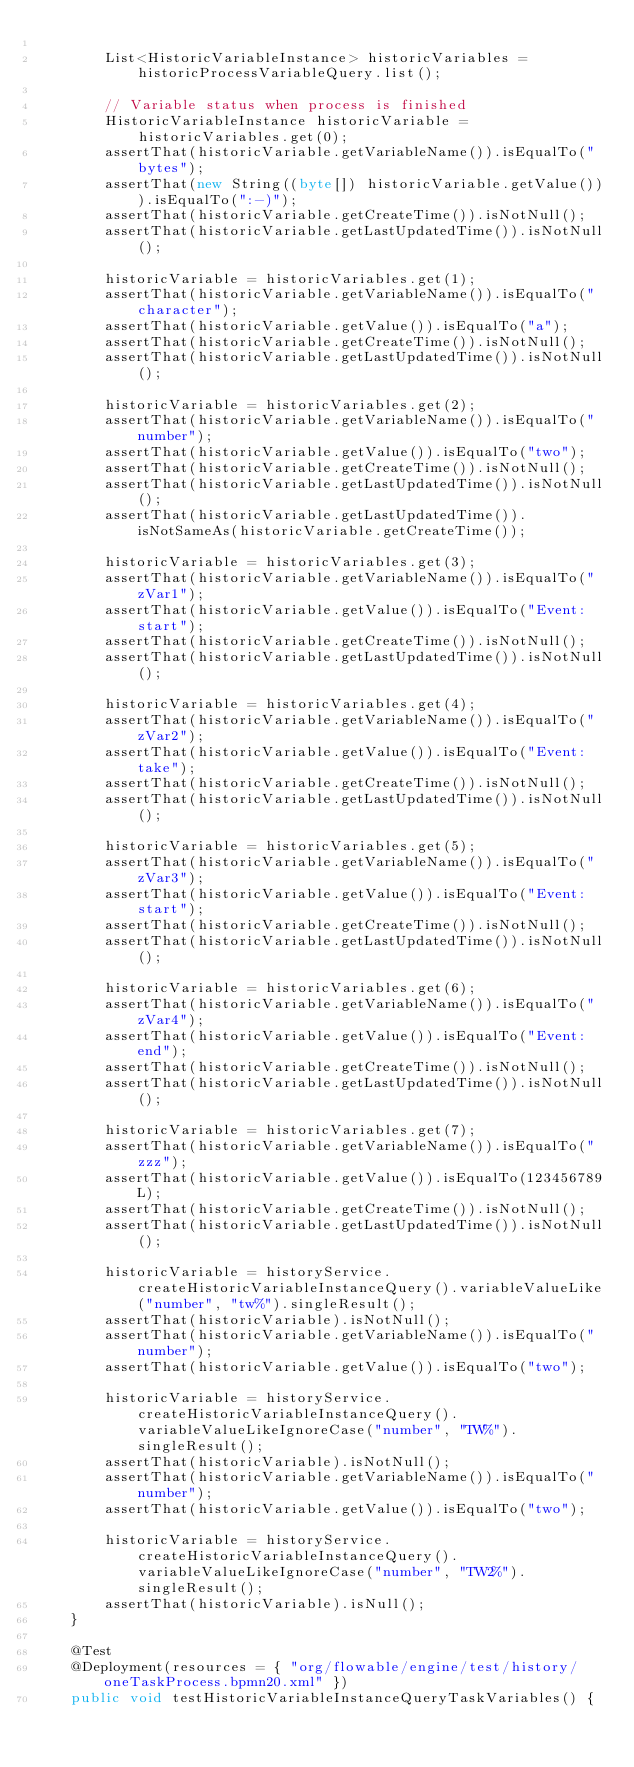Convert code to text. <code><loc_0><loc_0><loc_500><loc_500><_Java_>
        List<HistoricVariableInstance> historicVariables = historicProcessVariableQuery.list();

        // Variable status when process is finished
        HistoricVariableInstance historicVariable = historicVariables.get(0);
        assertThat(historicVariable.getVariableName()).isEqualTo("bytes");
        assertThat(new String((byte[]) historicVariable.getValue())).isEqualTo(":-)");
        assertThat(historicVariable.getCreateTime()).isNotNull();
        assertThat(historicVariable.getLastUpdatedTime()).isNotNull();

        historicVariable = historicVariables.get(1);
        assertThat(historicVariable.getVariableName()).isEqualTo("character");
        assertThat(historicVariable.getValue()).isEqualTo("a");
        assertThat(historicVariable.getCreateTime()).isNotNull();
        assertThat(historicVariable.getLastUpdatedTime()).isNotNull();

        historicVariable = historicVariables.get(2);
        assertThat(historicVariable.getVariableName()).isEqualTo("number");
        assertThat(historicVariable.getValue()).isEqualTo("two");
        assertThat(historicVariable.getCreateTime()).isNotNull();
        assertThat(historicVariable.getLastUpdatedTime()).isNotNull();
        assertThat(historicVariable.getLastUpdatedTime()).isNotSameAs(historicVariable.getCreateTime());

        historicVariable = historicVariables.get(3);
        assertThat(historicVariable.getVariableName()).isEqualTo("zVar1");
        assertThat(historicVariable.getValue()).isEqualTo("Event: start");
        assertThat(historicVariable.getCreateTime()).isNotNull();
        assertThat(historicVariable.getLastUpdatedTime()).isNotNull();

        historicVariable = historicVariables.get(4);
        assertThat(historicVariable.getVariableName()).isEqualTo("zVar2");
        assertThat(historicVariable.getValue()).isEqualTo("Event: take");
        assertThat(historicVariable.getCreateTime()).isNotNull();
        assertThat(historicVariable.getLastUpdatedTime()).isNotNull();

        historicVariable = historicVariables.get(5);
        assertThat(historicVariable.getVariableName()).isEqualTo("zVar3");
        assertThat(historicVariable.getValue()).isEqualTo("Event: start");
        assertThat(historicVariable.getCreateTime()).isNotNull();
        assertThat(historicVariable.getLastUpdatedTime()).isNotNull();

        historicVariable = historicVariables.get(6);
        assertThat(historicVariable.getVariableName()).isEqualTo("zVar4");
        assertThat(historicVariable.getValue()).isEqualTo("Event: end");
        assertThat(historicVariable.getCreateTime()).isNotNull();
        assertThat(historicVariable.getLastUpdatedTime()).isNotNull();

        historicVariable = historicVariables.get(7);
        assertThat(historicVariable.getVariableName()).isEqualTo("zzz");
        assertThat(historicVariable.getValue()).isEqualTo(123456789L);
        assertThat(historicVariable.getCreateTime()).isNotNull();
        assertThat(historicVariable.getLastUpdatedTime()).isNotNull();

        historicVariable = historyService.createHistoricVariableInstanceQuery().variableValueLike("number", "tw%").singleResult();
        assertThat(historicVariable).isNotNull();
        assertThat(historicVariable.getVariableName()).isEqualTo("number");
        assertThat(historicVariable.getValue()).isEqualTo("two");

        historicVariable = historyService.createHistoricVariableInstanceQuery().variableValueLikeIgnoreCase("number", "TW%").singleResult();
        assertThat(historicVariable).isNotNull();
        assertThat(historicVariable.getVariableName()).isEqualTo("number");
        assertThat(historicVariable.getValue()).isEqualTo("two");

        historicVariable = historyService.createHistoricVariableInstanceQuery().variableValueLikeIgnoreCase("number", "TW2%").singleResult();
        assertThat(historicVariable).isNull();
    }

    @Test
    @Deployment(resources = { "org/flowable/engine/test/history/oneTaskProcess.bpmn20.xml" })
    public void testHistoricVariableInstanceQueryTaskVariables() {</code> 